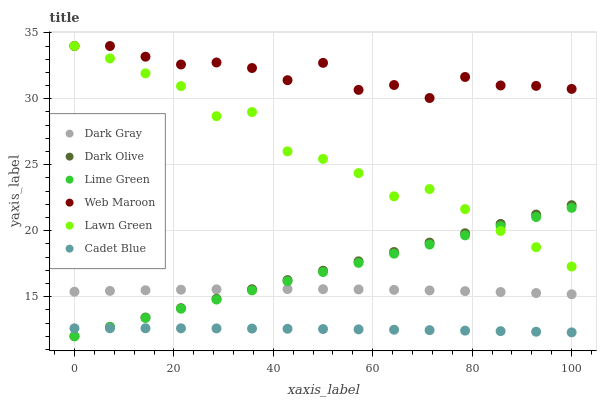Does Cadet Blue have the minimum area under the curve?
Answer yes or no. Yes. Does Web Maroon have the maximum area under the curve?
Answer yes or no. Yes. Does Dark Olive have the minimum area under the curve?
Answer yes or no. No. Does Dark Olive have the maximum area under the curve?
Answer yes or no. No. Is Dark Olive the smoothest?
Answer yes or no. Yes. Is Web Maroon the roughest?
Answer yes or no. Yes. Is Cadet Blue the smoothest?
Answer yes or no. No. Is Cadet Blue the roughest?
Answer yes or no. No. Does Dark Olive have the lowest value?
Answer yes or no. Yes. Does Cadet Blue have the lowest value?
Answer yes or no. No. Does Web Maroon have the highest value?
Answer yes or no. Yes. Does Dark Olive have the highest value?
Answer yes or no. No. Is Dark Olive less than Web Maroon?
Answer yes or no. Yes. Is Dark Gray greater than Cadet Blue?
Answer yes or no. Yes. Does Cadet Blue intersect Dark Olive?
Answer yes or no. Yes. Is Cadet Blue less than Dark Olive?
Answer yes or no. No. Is Cadet Blue greater than Dark Olive?
Answer yes or no. No. Does Dark Olive intersect Web Maroon?
Answer yes or no. No. 